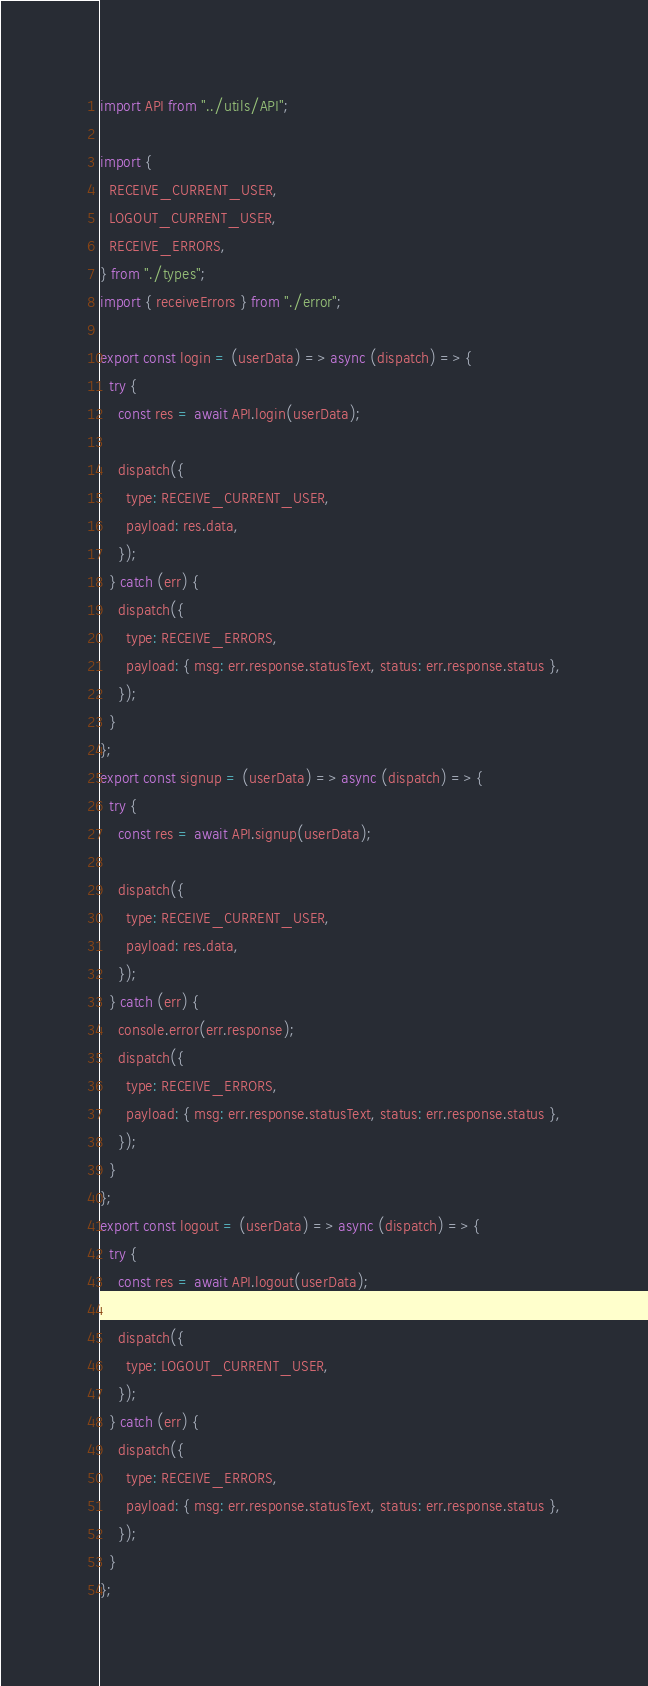Convert code to text. <code><loc_0><loc_0><loc_500><loc_500><_JavaScript_>import API from "../utils/API";

import {
  RECEIVE_CURRENT_USER,
  LOGOUT_CURRENT_USER,
  RECEIVE_ERRORS,
} from "./types";
import { receiveErrors } from "./error";

export const login = (userData) => async (dispatch) => {
  try {
    const res = await API.login(userData);

    dispatch({
      type: RECEIVE_CURRENT_USER,
      payload: res.data,
    });
  } catch (err) {
    dispatch({
      type: RECEIVE_ERRORS,
      payload: { msg: err.response.statusText, status: err.response.status },
    });
  }
};
export const signup = (userData) => async (dispatch) => {
  try {
    const res = await API.signup(userData);

    dispatch({
      type: RECEIVE_CURRENT_USER,
      payload: res.data,
    });
  } catch (err) {
    console.error(err.response);
    dispatch({
      type: RECEIVE_ERRORS,
      payload: { msg: err.response.statusText, status: err.response.status },
    });
  }
};
export const logout = (userData) => async (dispatch) => {
  try {
    const res = await API.logout(userData);

    dispatch({
      type: LOGOUT_CURRENT_USER,
    });
  } catch (err) {
    dispatch({
      type: RECEIVE_ERRORS,
      payload: { msg: err.response.statusText, status: err.response.status },
    });
  }
};
</code> 